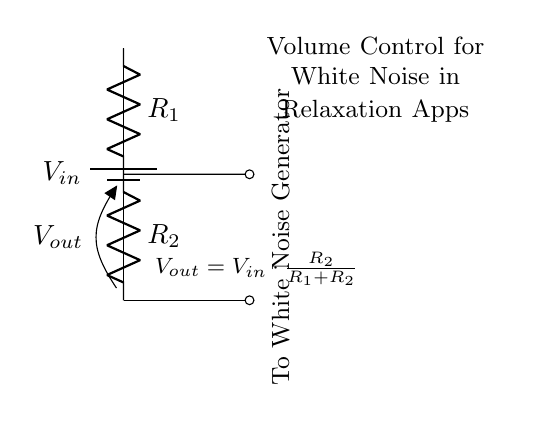What is the input voltage in this circuit? The circuit diagram indicates that the input voltage is labeled as \(V_{in}\), which is typically the voltage supplied to the circuit from the battery.
Answer: \(V_{in}\) What are the resistances in this voltage divider? The circuit diagram shows two resistors, \(R_1\) and \(R_2\), which are part of the voltage divider. These values are critical for calculating the output voltage.
Answer: \(R_1\), \(R_2\) What is the output voltage formula in this diagram? The output voltage, \(V_{out}\), is expressed in the diagram as \(V_{out} = V_{in} \cdot \frac{R_2}{R_1 + R_2}\). This formula shows how the output voltage is dependent on the input voltage and the resistors' values.
Answer: \(V_{out} = V_{in} \cdot \frac{R_2}{R_1 + R_2}\) How does changing \(R_2\) affect \(V_{out}\)? Increasing \(R_2\) while keeping \(R_1\) constant will result in a higher output voltage, because the fraction \(\frac{R_2}{R_1 + R_2}\) increases, thus raising \(V_{out}\). Conversely, decreasing \(R_2\) will yield a lower output.
Answer: Increases \(V_{out}\) What is the purpose of this voltage divider in the context of relaxation apps? The voltage divider in this circuit is used to control the volume of the white noise generator in relaxation apps, allowing users to adjust how loud or soft the sound is, enhancing the relaxation experience.
Answer: Volume control for white noise generator What happens to \(V_{out}\) if both resistors are equal? If \(R_1\) equals \(R_2\), the output voltage \(V_{out}\) will be half of \(V_{in}\) according to the formula provided. This is due to the equal division of voltage across the two resistors.
Answer: \(V_{out} = \frac{1}{2}V_{in}\) How would you connect the output in this application? The output \(V_{out}\) from the voltage divider connects to the white noise generator, which receives the controlled volume signal for sound production in the app.
Answer: To White Noise Generator 